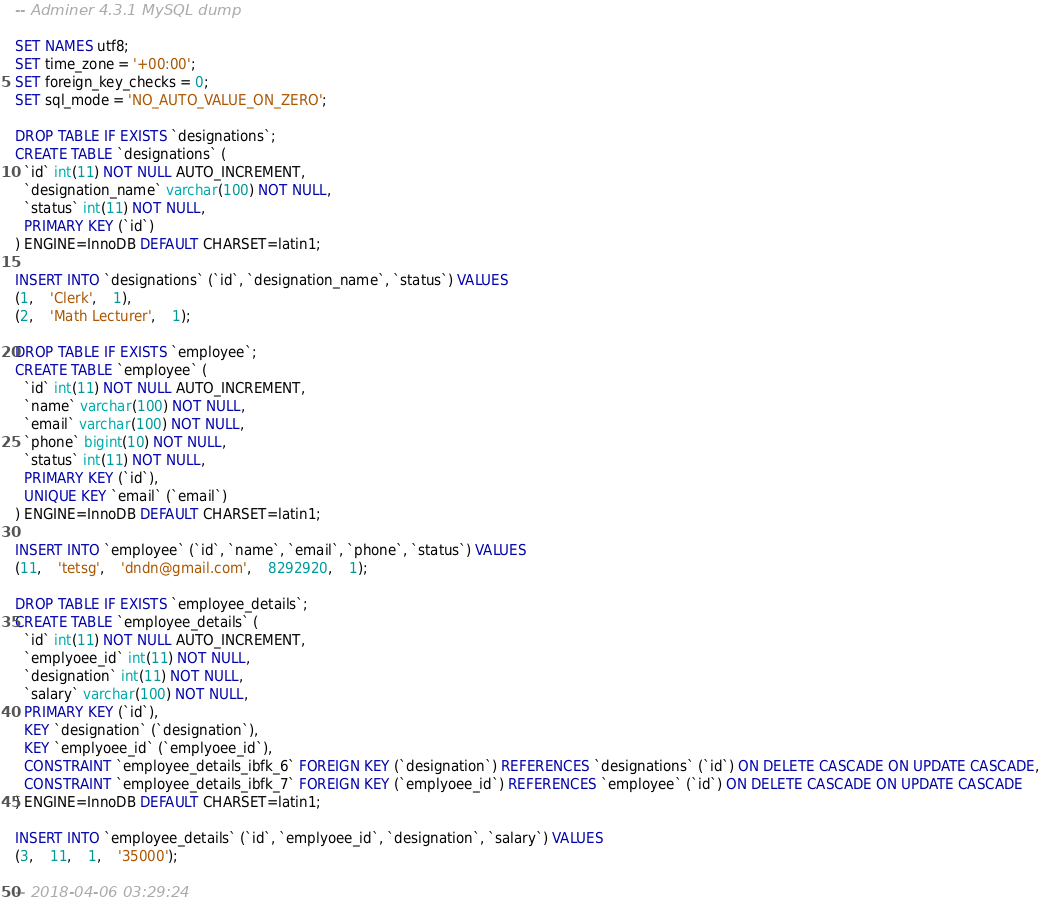Convert code to text. <code><loc_0><loc_0><loc_500><loc_500><_SQL_>

-- Adminer 4.3.1 MySQL dump

SET NAMES utf8;
SET time_zone = '+00:00';
SET foreign_key_checks = 0;
SET sql_mode = 'NO_AUTO_VALUE_ON_ZERO';

DROP TABLE IF EXISTS `designations`;
CREATE TABLE `designations` (
  `id` int(11) NOT NULL AUTO_INCREMENT,
  `designation_name` varchar(100) NOT NULL,
  `status` int(11) NOT NULL,
  PRIMARY KEY (`id`)
) ENGINE=InnoDB DEFAULT CHARSET=latin1;

INSERT INTO `designations` (`id`, `designation_name`, `status`) VALUES
(1,	'Clerk',	1),
(2,	'Math Lecturer',	1);

DROP TABLE IF EXISTS `employee`;
CREATE TABLE `employee` (
  `id` int(11) NOT NULL AUTO_INCREMENT,
  `name` varchar(100) NOT NULL,
  `email` varchar(100) NOT NULL,
  `phone` bigint(10) NOT NULL,
  `status` int(11) NOT NULL,
  PRIMARY KEY (`id`),
  UNIQUE KEY `email` (`email`)
) ENGINE=InnoDB DEFAULT CHARSET=latin1;

INSERT INTO `employee` (`id`, `name`, `email`, `phone`, `status`) VALUES
(11,	'tetsg',	'dndn@gmail.com',	8292920,	1);

DROP TABLE IF EXISTS `employee_details`;
CREATE TABLE `employee_details` (
  `id` int(11) NOT NULL AUTO_INCREMENT,
  `emplyoee_id` int(11) NOT NULL,
  `designation` int(11) NOT NULL,
  `salary` varchar(100) NOT NULL,
  PRIMARY KEY (`id`),
  KEY `designation` (`designation`),
  KEY `emplyoee_id` (`emplyoee_id`),
  CONSTRAINT `employee_details_ibfk_6` FOREIGN KEY (`designation`) REFERENCES `designations` (`id`) ON DELETE CASCADE ON UPDATE CASCADE,
  CONSTRAINT `employee_details_ibfk_7` FOREIGN KEY (`emplyoee_id`) REFERENCES `employee` (`id`) ON DELETE CASCADE ON UPDATE CASCADE
) ENGINE=InnoDB DEFAULT CHARSET=latin1;

INSERT INTO `employee_details` (`id`, `emplyoee_id`, `designation`, `salary`) VALUES
(3,	11,	1,	'35000');

-- 2018-04-06 03:29:24
</code> 